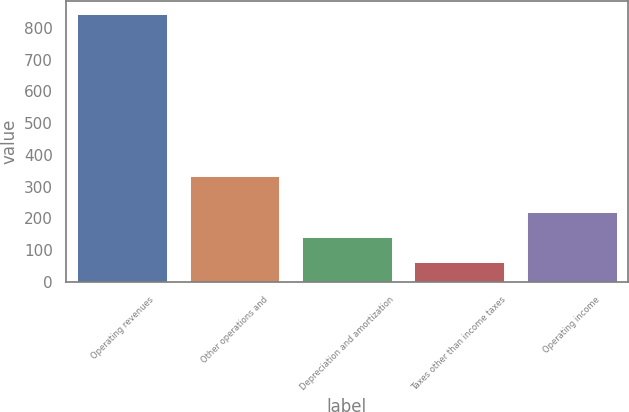Convert chart to OTSL. <chart><loc_0><loc_0><loc_500><loc_500><bar_chart><fcel>Operating revenues<fcel>Other operations and<fcel>Depreciation and amortization<fcel>Taxes other than income taxes<fcel>Operating income<nl><fcel>845<fcel>333<fcel>140.3<fcel>62<fcel>218.6<nl></chart> 